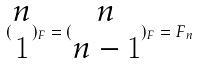Convert formula to latex. <formula><loc_0><loc_0><loc_500><loc_500>( \begin{matrix} n \\ 1 \end{matrix} ) _ { F } = ( \begin{matrix} n \\ n - 1 \end{matrix} ) _ { F } = F _ { n }</formula> 